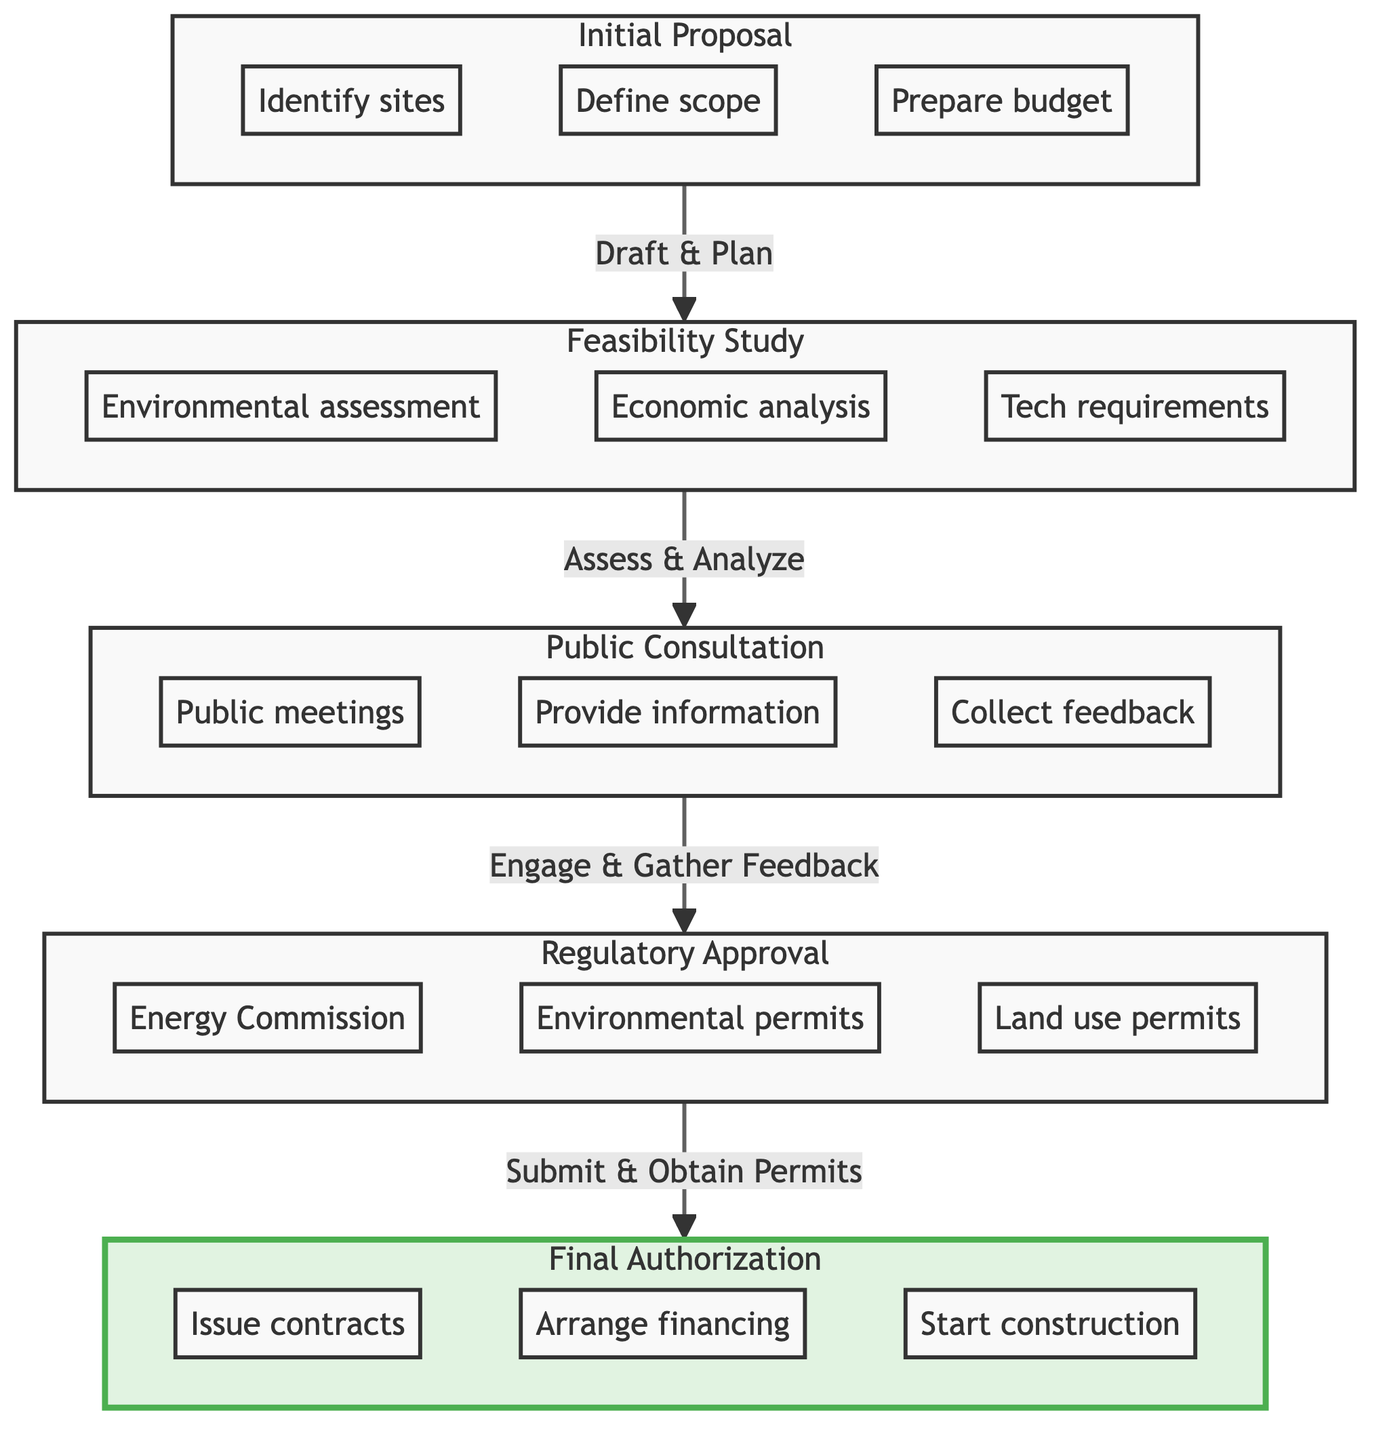What is the first step in the process? The first node in the flow chart is "Initial Proposal," which indicates it is the starting point of the legal process for approving a renewable energy project.
Answer: Initial Proposal How many steps are there in the process? There are five distinct nodes in the flow chart, which represent the steps in the process, starting from the Initial Proposal to Final Authorization.
Answer: 5 What follows the Feasibility Study? In the flow chart, the arrow points from "Feasibility Study" to "Public Consultation," indicating that the public consultation follows the feasibility study.
Answer: Public Consultation Which step involves community engagement? The "Public Consultation" step focuses on engaging with the local community and stakeholders to gather their feedback about the proposed project.
Answer: Public Consultation What action is associated with Regulatory Approval? The three actions listed under "Regulatory Approval" include filing applications, obtaining environmental permits, and securing land use permits, indicating these are key actions in this step.
Answer: File applications Which final action occurs in Final Authorization? The final node, "Final Authorization," includes actions like issuing final project contracts, which indicates this is a critical action that occurs during the final stage of the approval process.
Answer: Issue final project contracts What is the last step before Final Authorization? The step preceding "Final Authorization" is "Regulatory Approval," which outlines the necessary permits and approvals needed before final project authorization can begin.
Answer: Regulatory Approval How does the Feasibility Study contribute to public consultation? The Feasibility Study assesses the project's viability, and this information is crucial during the Public Consultation phase, as stakeholders will want to know about the study's findings before engaging in discussions.
Answer: By assessing viability What type of permits are obtained during Regulatory Approval? The "Regulatory Approval" step specifies obtaining three types of permits: environmental permits, land use permits, and permits from the Energy Regulatory Commission.
Answer: Environmental permits, land use permits 